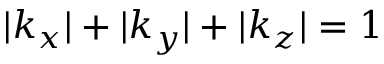Convert formula to latex. <formula><loc_0><loc_0><loc_500><loc_500>| k _ { x } | + | k _ { y } | + | k _ { z } | = 1</formula> 